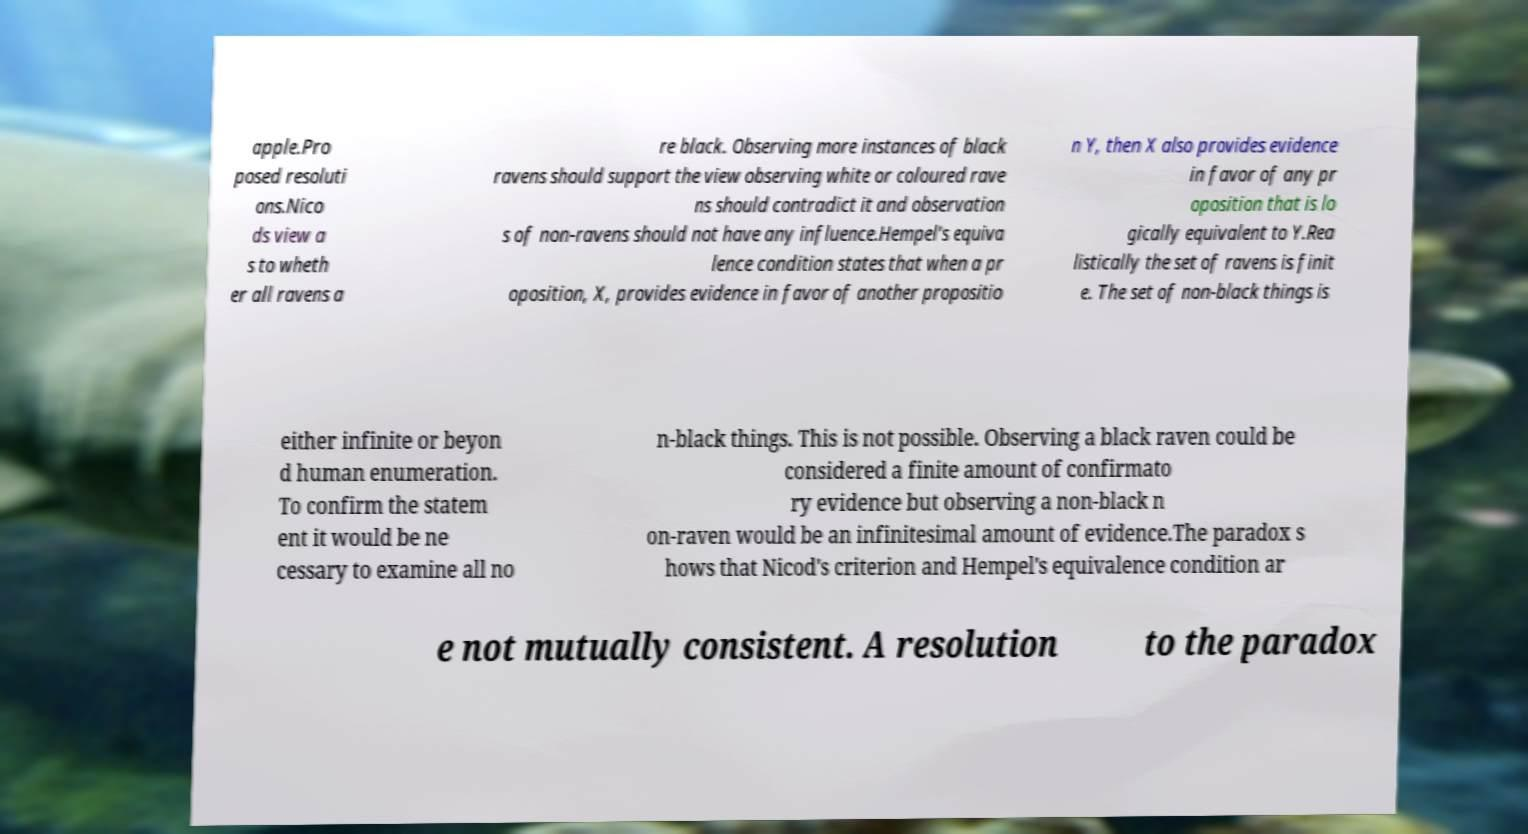Can you accurately transcribe the text from the provided image for me? apple.Pro posed resoluti ons.Nico ds view a s to wheth er all ravens a re black. Observing more instances of black ravens should support the view observing white or coloured rave ns should contradict it and observation s of non-ravens should not have any influence.Hempel's equiva lence condition states that when a pr oposition, X, provides evidence in favor of another propositio n Y, then X also provides evidence in favor of any pr oposition that is lo gically equivalent to Y.Rea listically the set of ravens is finit e. The set of non-black things is either infinite or beyon d human enumeration. To confirm the statem ent it would be ne cessary to examine all no n-black things. This is not possible. Observing a black raven could be considered a finite amount of confirmato ry evidence but observing a non-black n on-raven would be an infinitesimal amount of evidence.The paradox s hows that Nicod's criterion and Hempel's equivalence condition ar e not mutually consistent. A resolution to the paradox 